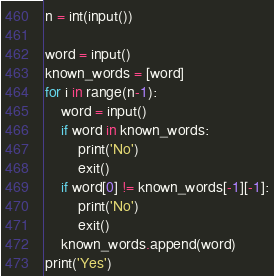<code> <loc_0><loc_0><loc_500><loc_500><_Python_>n = int(input())

word = input()
known_words = [word]
for i in range(n-1):
    word = input()
    if word in known_words:
        print('No')
        exit()
    if word[0] != known_words[-1][-1]:
        print('No')
        exit()
    known_words.append(word)
print('Yes')
</code> 